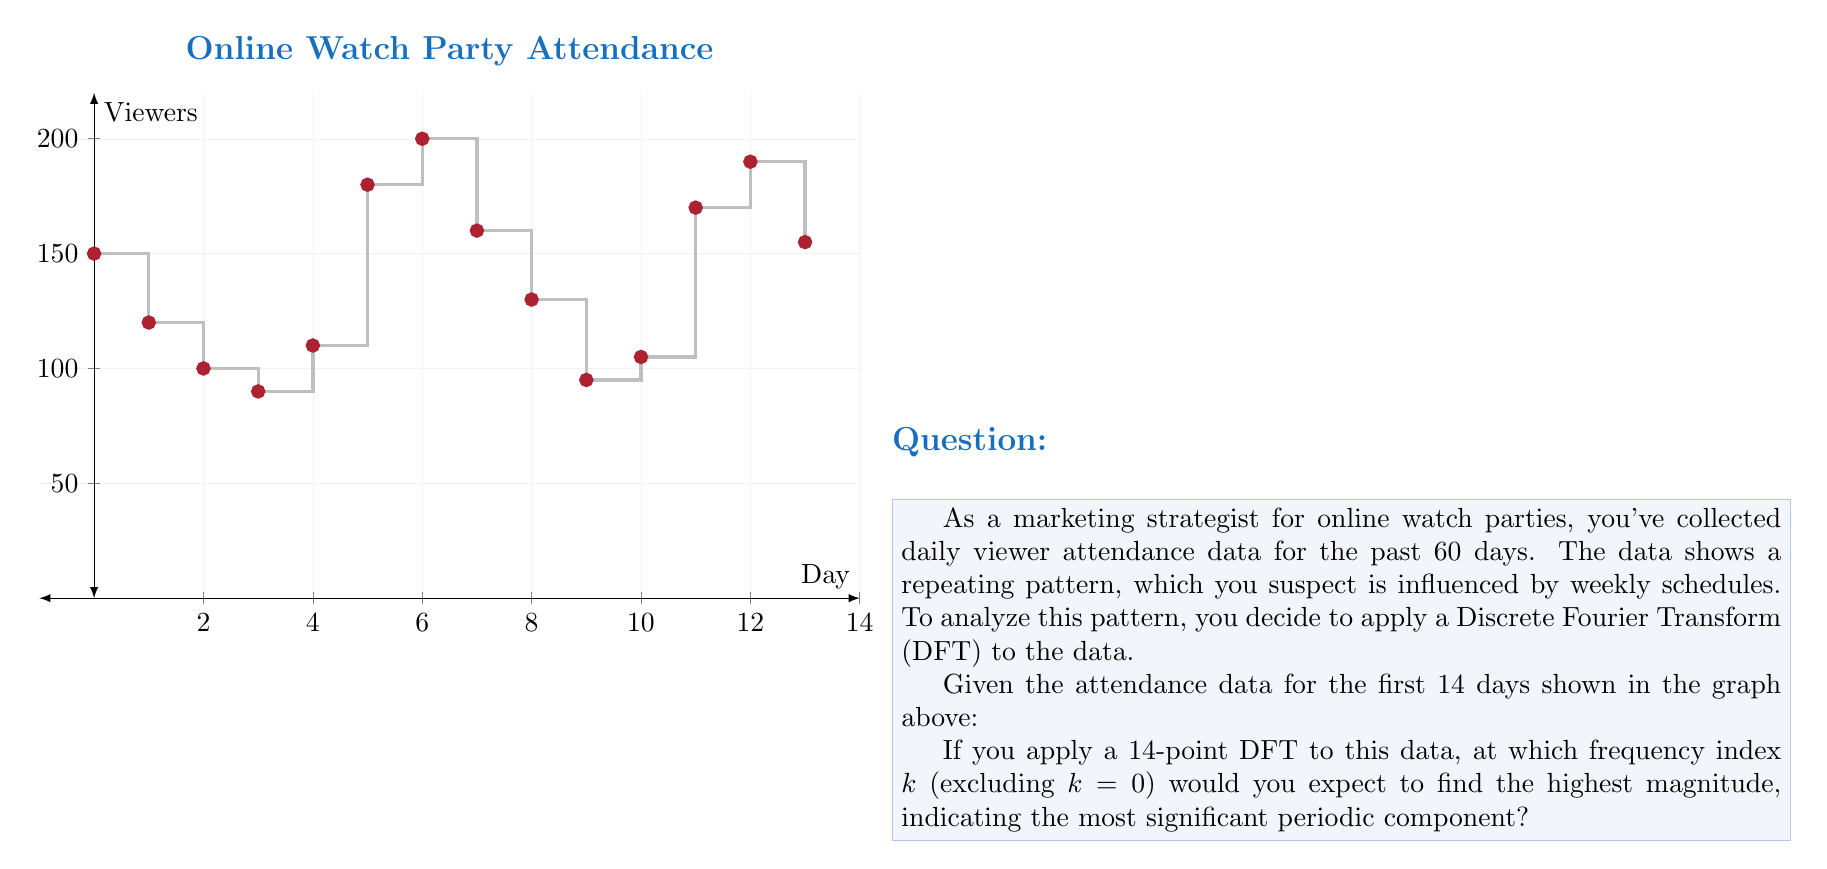Can you answer this question? To solve this problem, we need to understand the relationship between the DFT frequency index and the actual frequency in the data:

1) In a 14-point DFT, the frequency resolution is $\frac{1}{14}$ cycles per sample.

2) We suspect a weekly pattern, which means a period of 7 days.

3) To find the corresponding frequency index $k$, we use the formula:

   $$k = N \cdot \frac{f_{\text{actual}}}{f_s}$$

   Where $N$ is the number of points (14), $f_{\text{actual}}$ is the actual frequency (1/7 cycles/day), and $f_s$ is the sampling frequency (1 sample/day).

4) Plugging in the values:

   $$k = 14 \cdot \frac{1/7}{1} = 2$$

5) This means the 2nd frequency component (k=2) corresponds to a 7-day period.

6) We round to the nearest integer because k must be an integer in the DFT.

Therefore, we expect the highest magnitude (excluding k=0) at k=2, which represents the weekly pattern in the data.
Answer: 2 